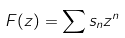<formula> <loc_0><loc_0><loc_500><loc_500>F ( z ) = \sum { s _ { n } z ^ { n } }</formula> 